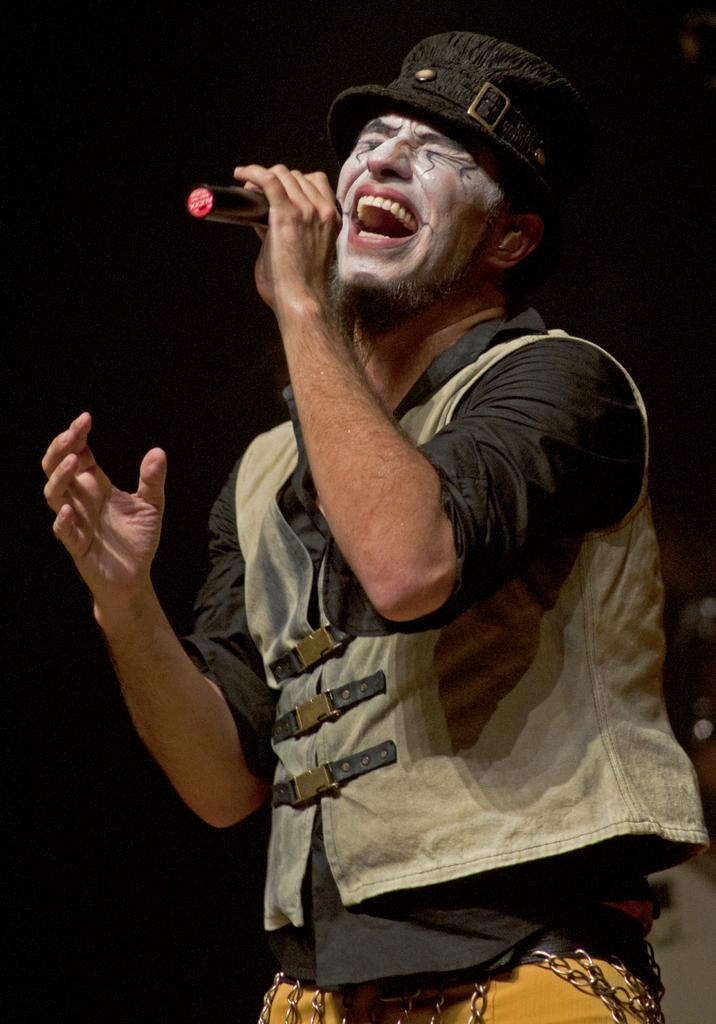What is the main subject of the image? The main subject of the image is a man. What is the man doing in the image? The man is standing and singing in the image. What object is the man holding in the image? The man is holding a microphone in the image. What accessories is the man wearing in the image? The man is wearing a cap and a coat in the image. What type of bean is the man holding in the image? There is no bean present in the image. 